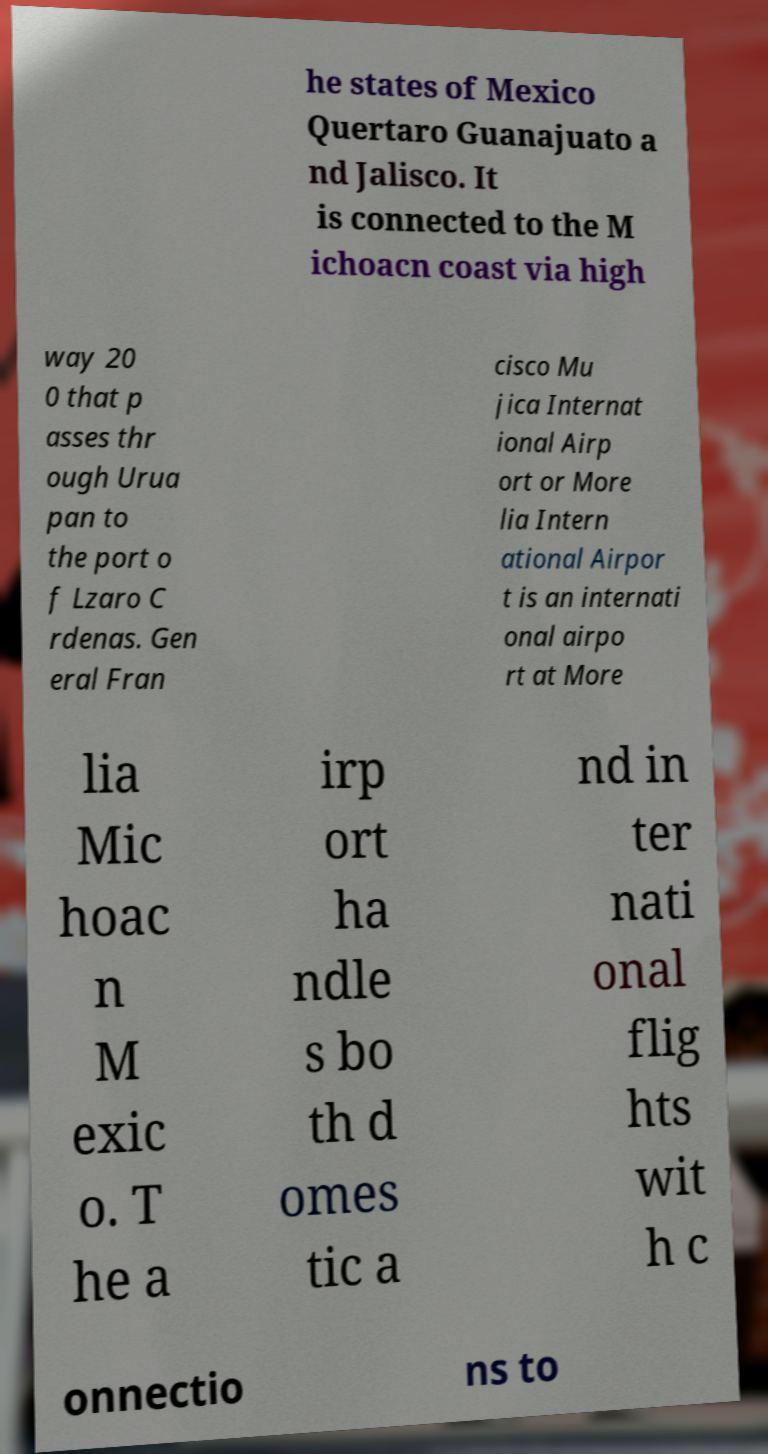There's text embedded in this image that I need extracted. Can you transcribe it verbatim? he states of Mexico Quertaro Guanajuato a nd Jalisco. It is connected to the M ichoacn coast via high way 20 0 that p asses thr ough Urua pan to the port o f Lzaro C rdenas. Gen eral Fran cisco Mu jica Internat ional Airp ort or More lia Intern ational Airpor t is an internati onal airpo rt at More lia Mic hoac n M exic o. T he a irp ort ha ndle s bo th d omes tic a nd in ter nati onal flig hts wit h c onnectio ns to 